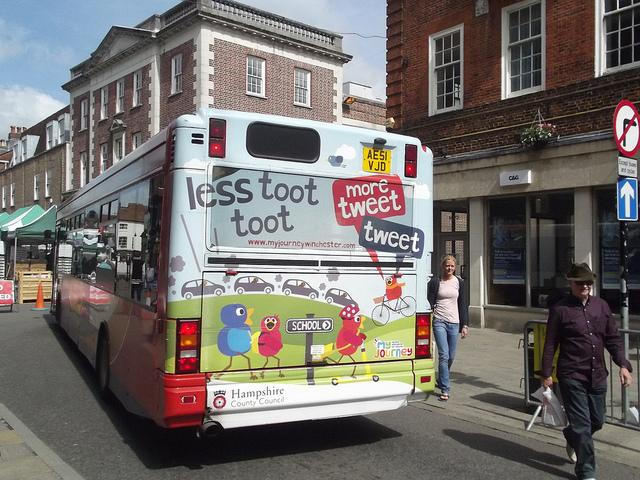Which direction will the bus go next? Please explain your reasoning. back up. In front of the bus there is visibly a cone and other items blocking the road that would prevent it from continuing in that direction. the bus has lights on the back that also indicate it is about to reverse. 